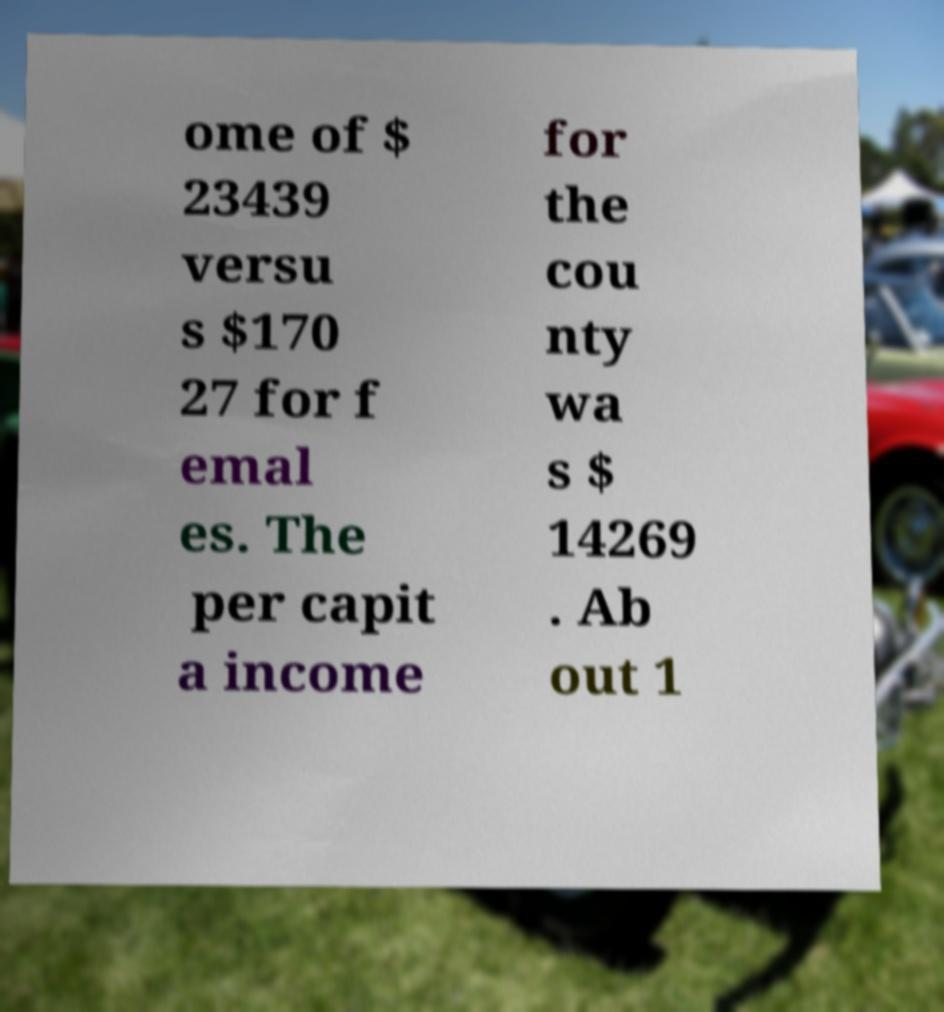There's text embedded in this image that I need extracted. Can you transcribe it verbatim? ome of $ 23439 versu s $170 27 for f emal es. The per capit a income for the cou nty wa s $ 14269 . Ab out 1 